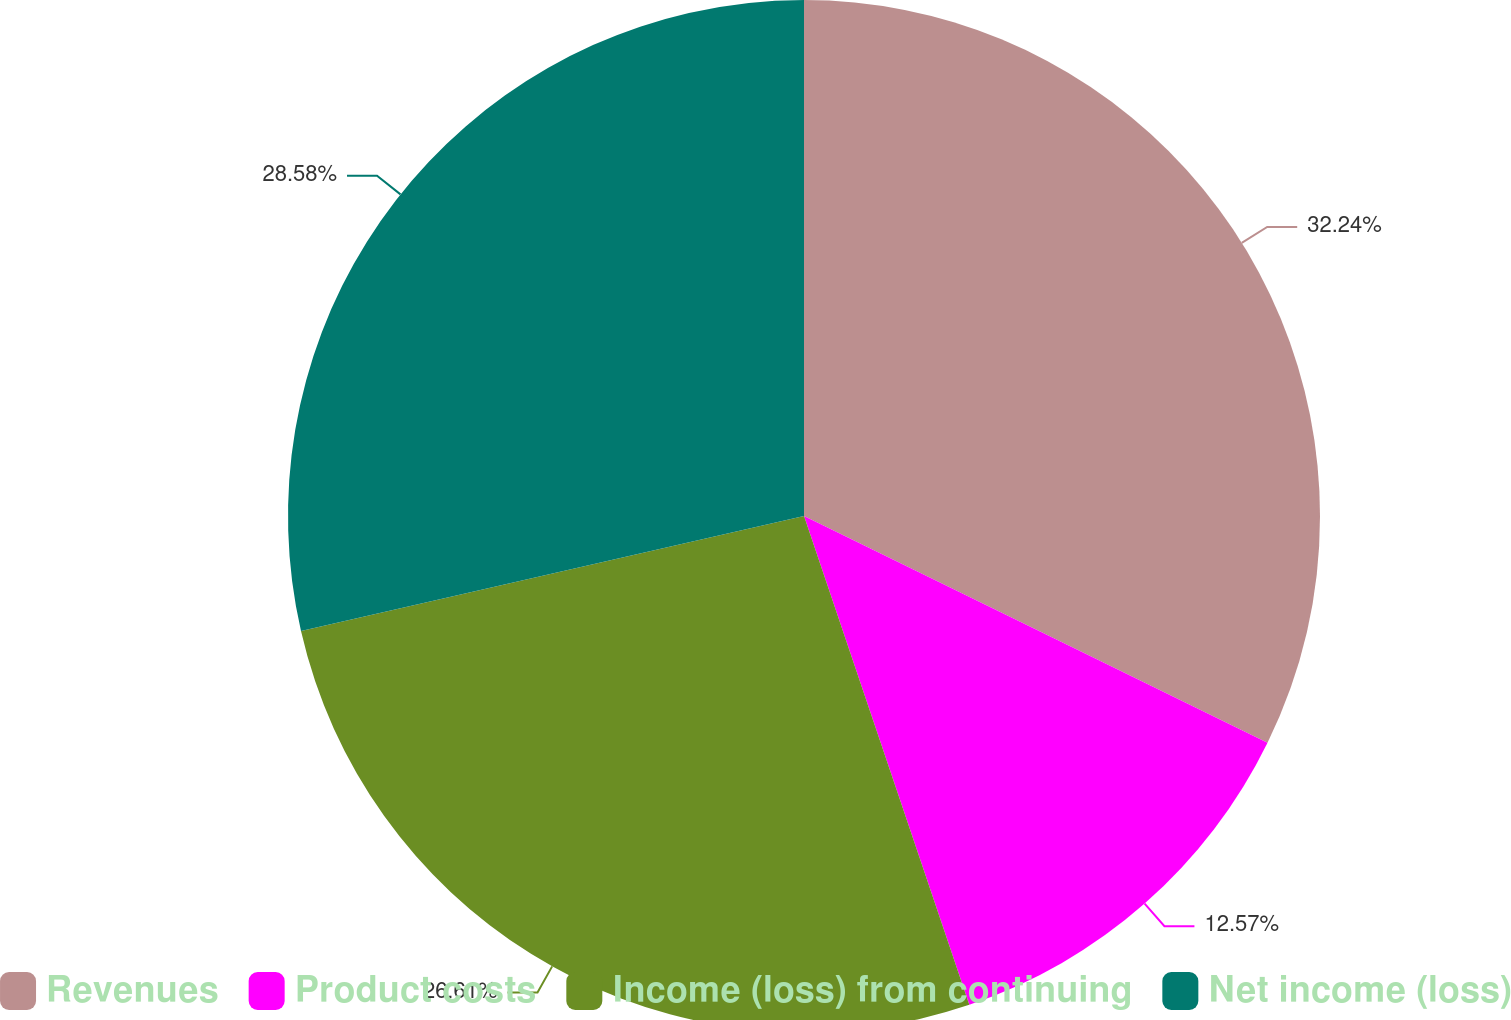<chart> <loc_0><loc_0><loc_500><loc_500><pie_chart><fcel>Revenues<fcel>Product costs<fcel>Income (loss) from continuing<fcel>Net income (loss)<nl><fcel>32.24%<fcel>12.57%<fcel>26.61%<fcel>28.58%<nl></chart> 